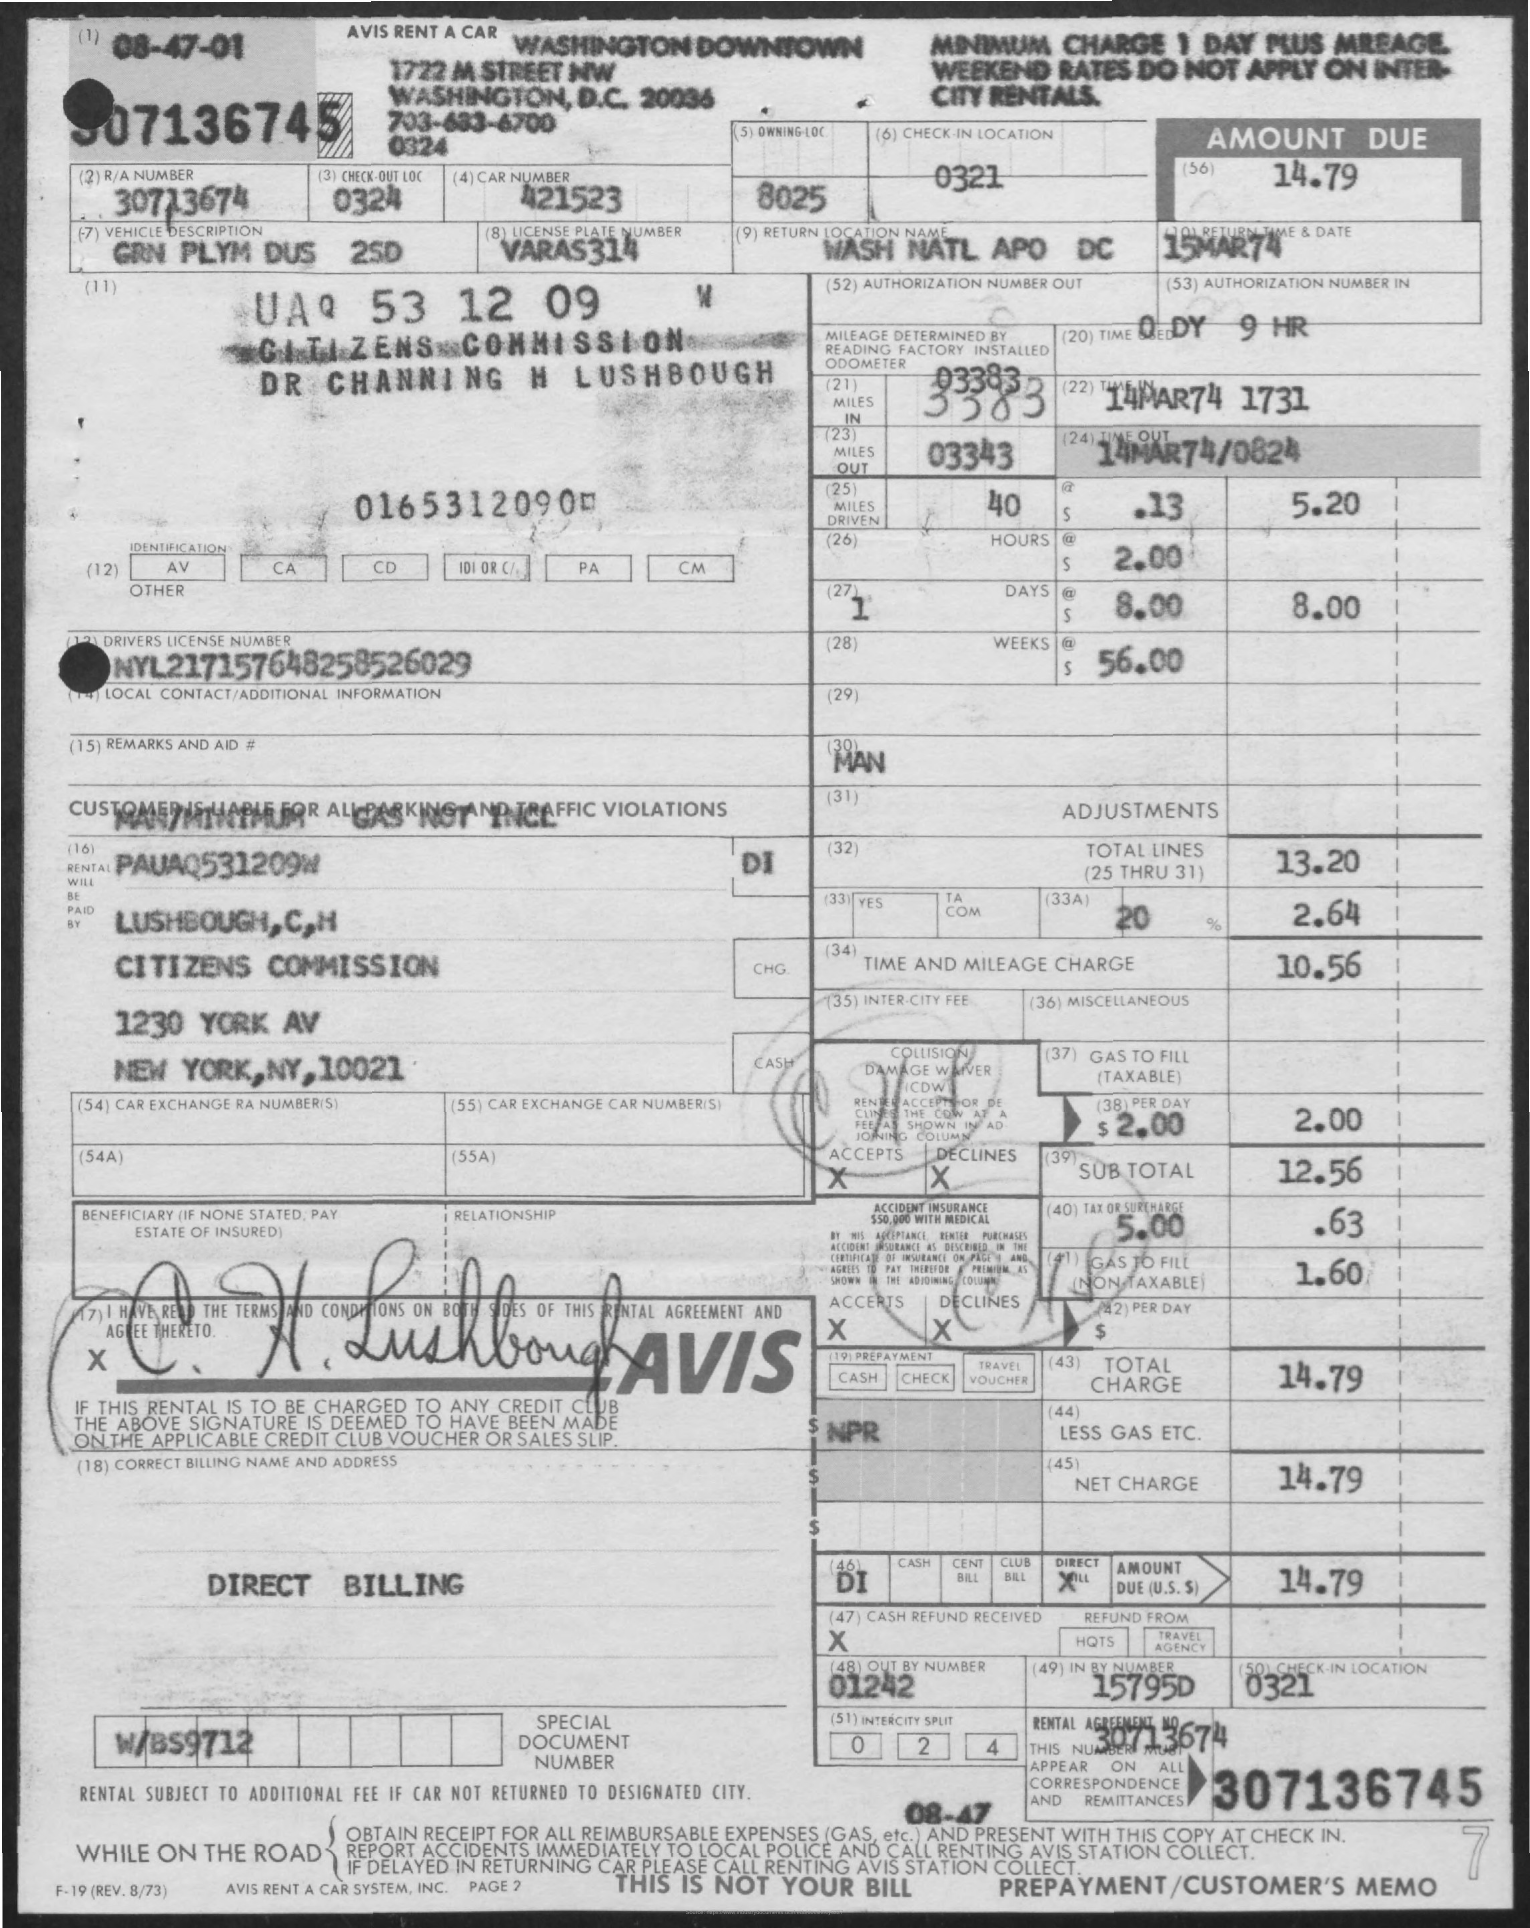What is the check-out LOC?
Provide a short and direct response. 0324. What is the car number?
Your answer should be compact. 421523. What is the vehicle description?
Provide a succinct answer. GRN PLYM DUS 2SD. What is the license plate number?
Make the answer very short. VARAS314. What is the return location name?
Offer a very short reply. WASH NATL APO DC. What is the return date?
Offer a terse response. 15MAR74. What is the DRIVERS LICENSE NUMBER?
Give a very brief answer. NYL217157648258526029. 